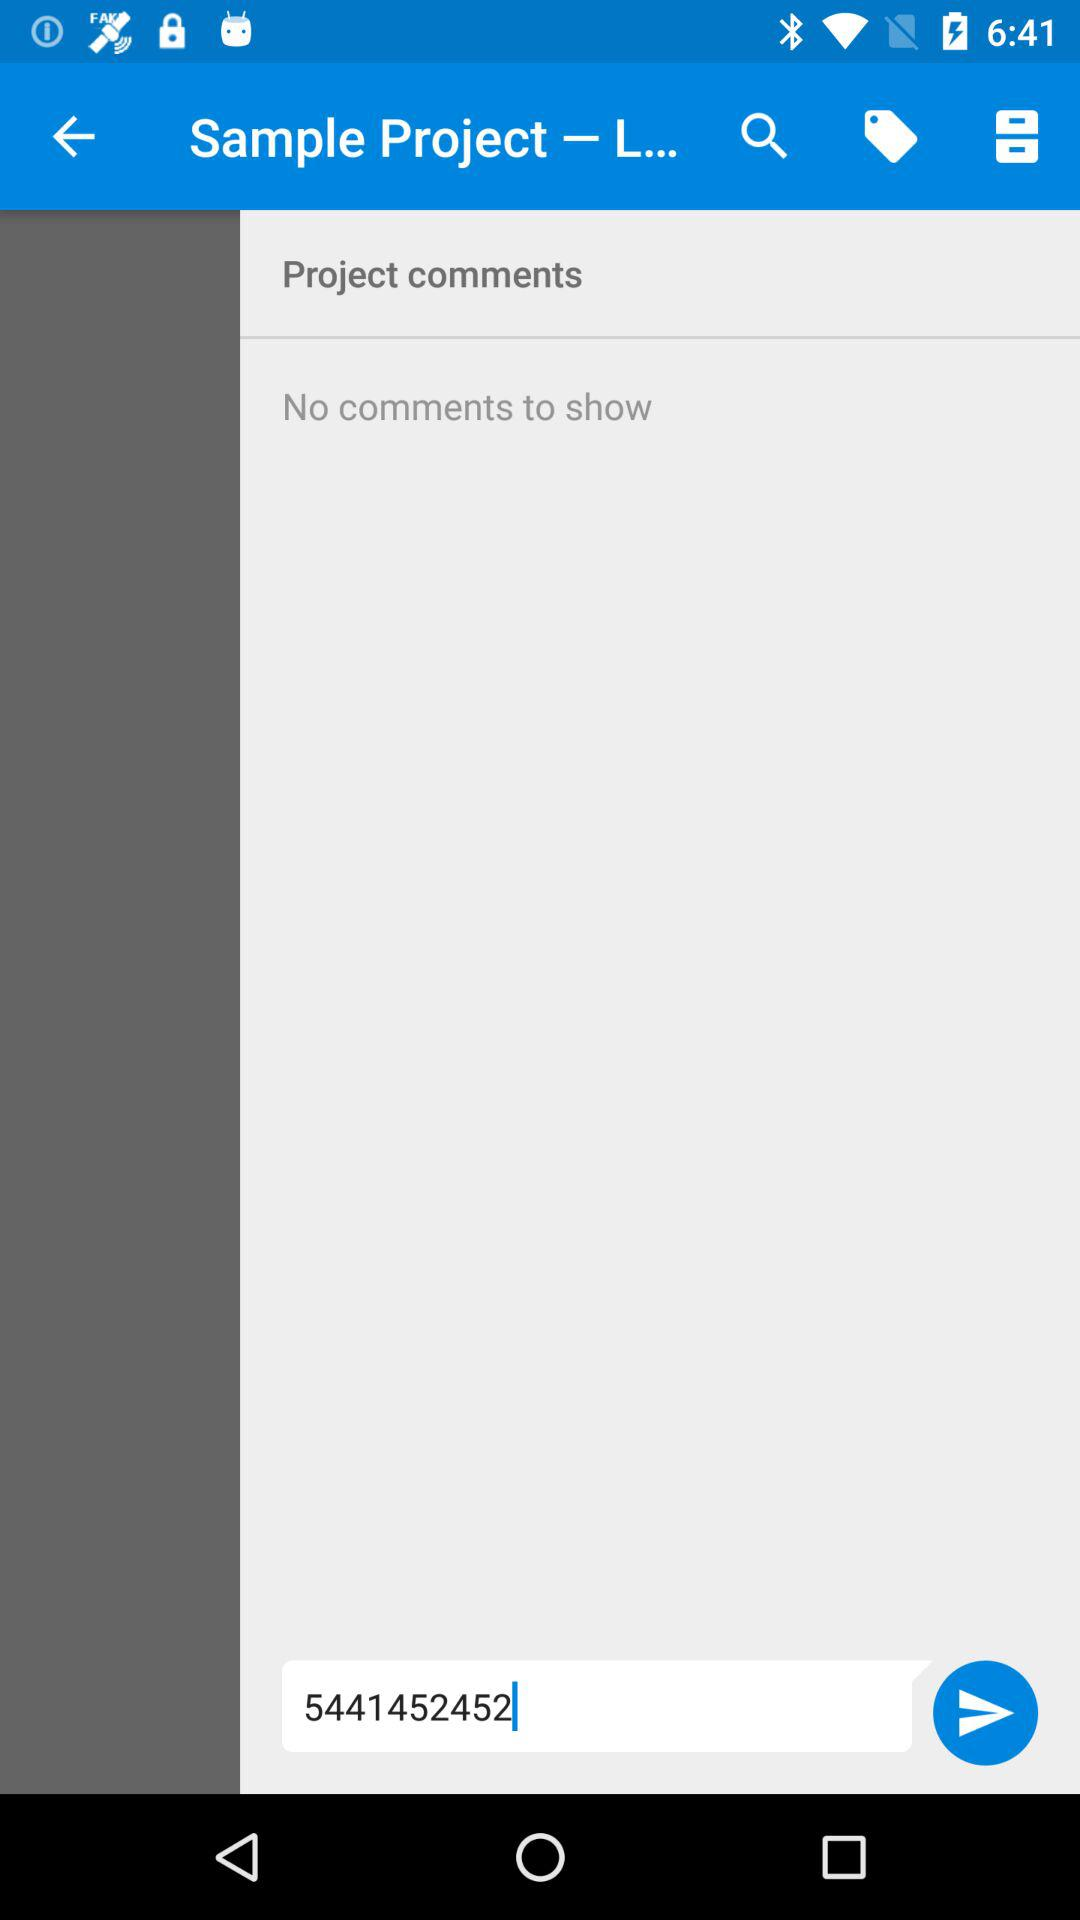What number is shown on the screen? The number shown on the screen is 5441452452. 